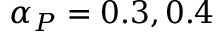<formula> <loc_0><loc_0><loc_500><loc_500>\alpha _ { P } = 0 . 3 , 0 . 4</formula> 